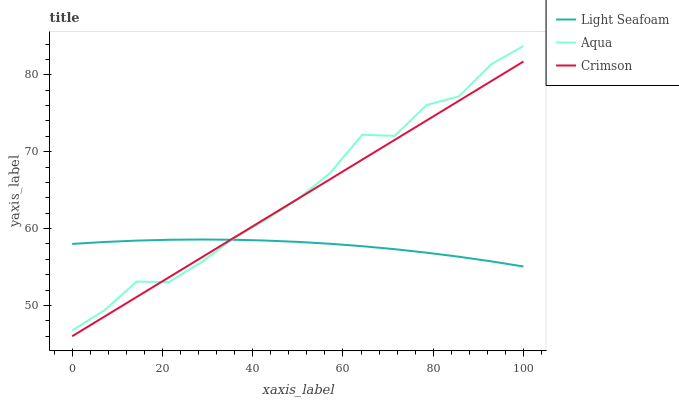Does Light Seafoam have the minimum area under the curve?
Answer yes or no. Yes. Does Aqua have the maximum area under the curve?
Answer yes or no. Yes. Does Aqua have the minimum area under the curve?
Answer yes or no. No. Does Light Seafoam have the maximum area under the curve?
Answer yes or no. No. Is Crimson the smoothest?
Answer yes or no. Yes. Is Aqua the roughest?
Answer yes or no. Yes. Is Light Seafoam the smoothest?
Answer yes or no. No. Is Light Seafoam the roughest?
Answer yes or no. No. Does Crimson have the lowest value?
Answer yes or no. Yes. Does Aqua have the lowest value?
Answer yes or no. No. Does Aqua have the highest value?
Answer yes or no. Yes. Does Light Seafoam have the highest value?
Answer yes or no. No. Does Crimson intersect Aqua?
Answer yes or no. Yes. Is Crimson less than Aqua?
Answer yes or no. No. Is Crimson greater than Aqua?
Answer yes or no. No. 